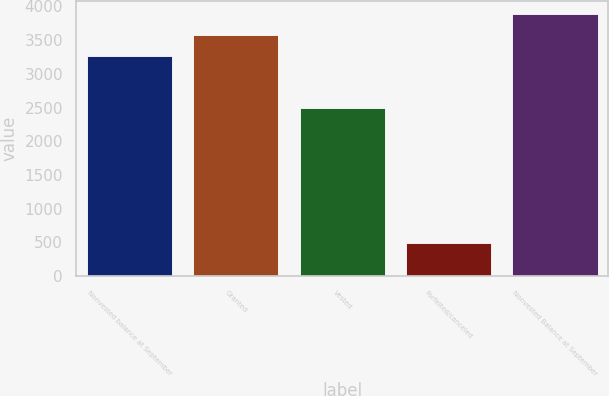Convert chart. <chart><loc_0><loc_0><loc_500><loc_500><bar_chart><fcel>Nonvested balance at September<fcel>Granted<fcel>Vested<fcel>Forfeited/canceled<fcel>Nonvested Balance at September<nl><fcel>3258<fcel>3574.3<fcel>2489<fcel>494<fcel>3890.6<nl></chart> 